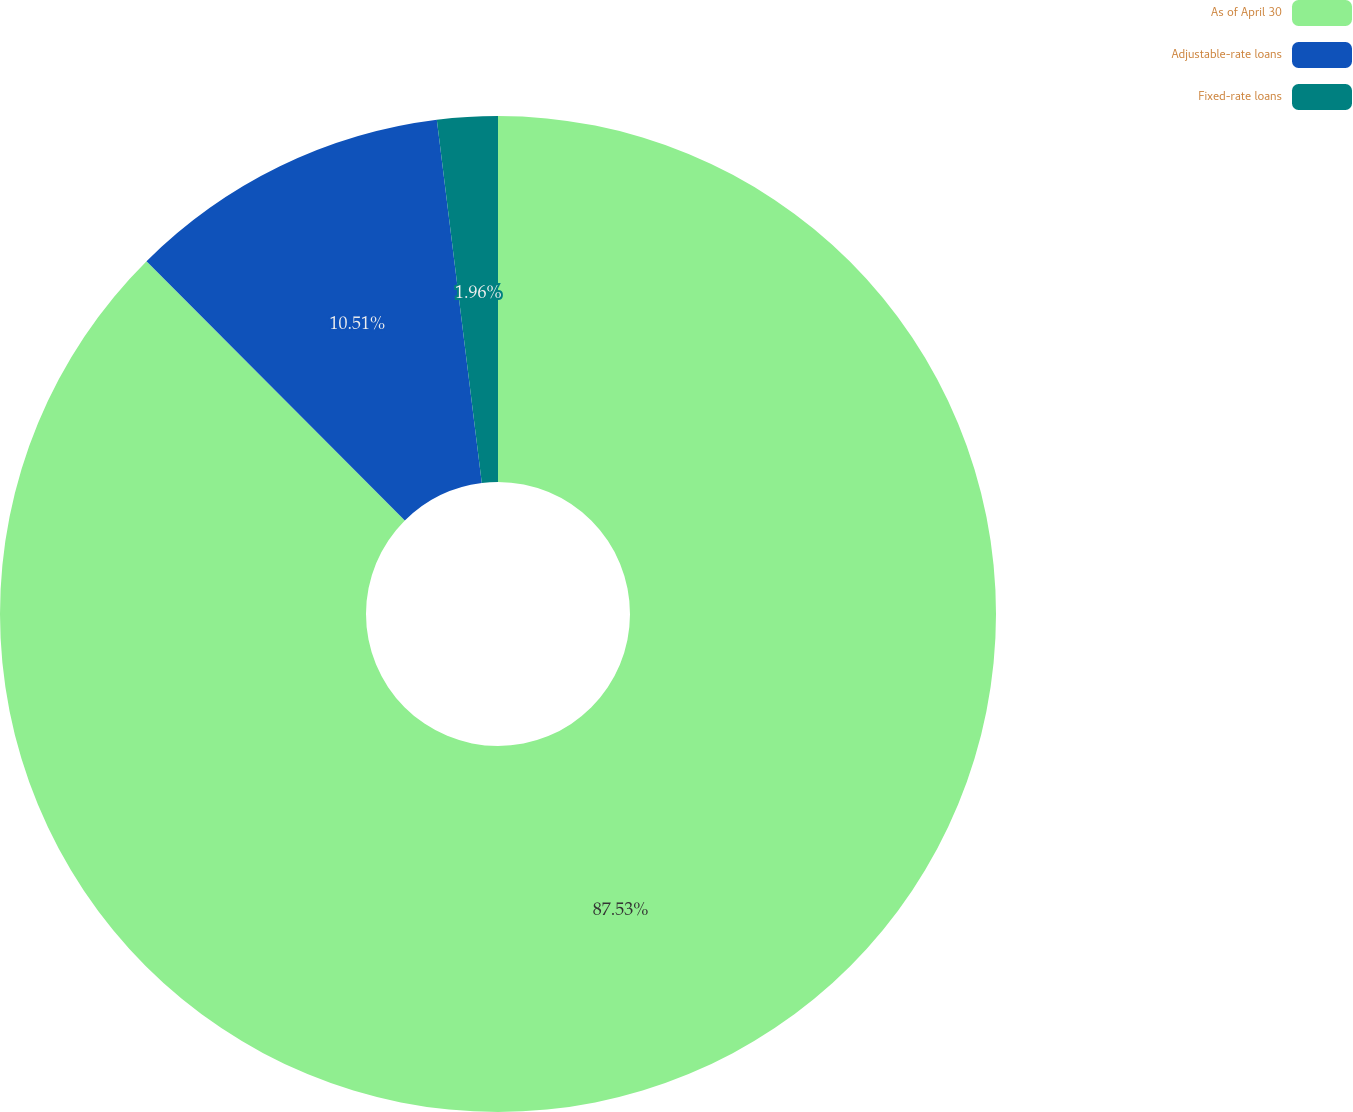Convert chart to OTSL. <chart><loc_0><loc_0><loc_500><loc_500><pie_chart><fcel>As of April 30<fcel>Adjustable-rate loans<fcel>Fixed-rate loans<nl><fcel>87.53%<fcel>10.51%<fcel>1.96%<nl></chart> 